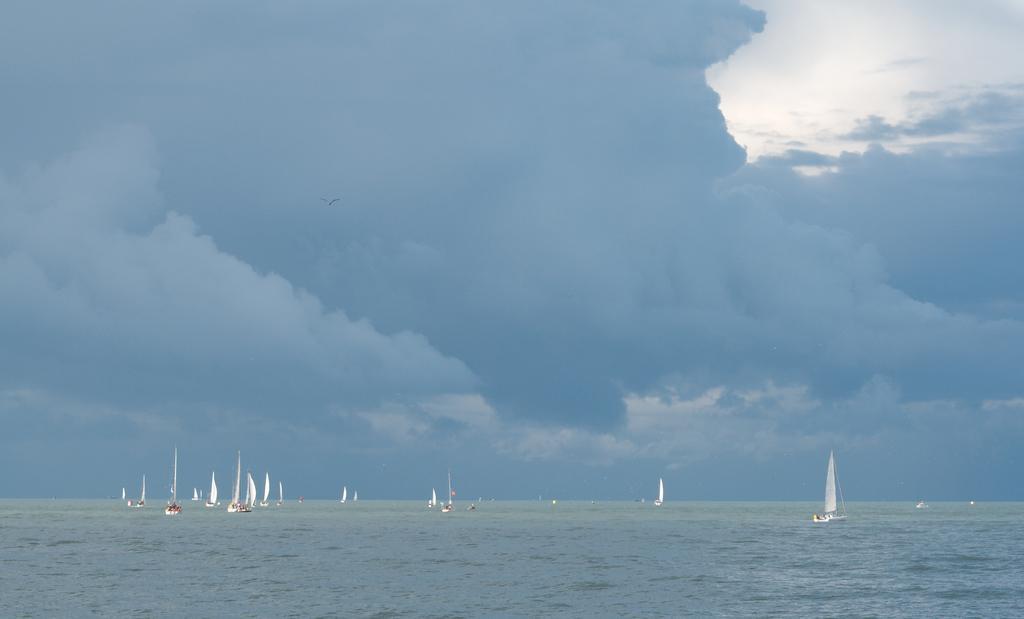Could you give a brief overview of what you see in this image? At the bottom of the image we can see boats in sea. In the background we can see clouds and sky. 